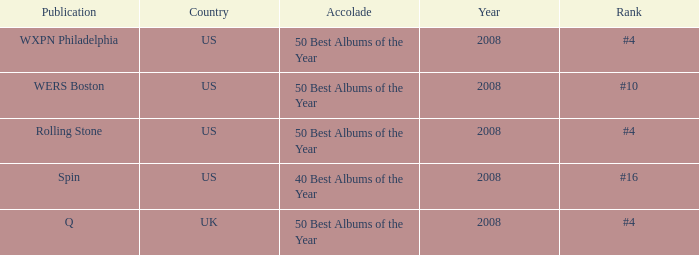In which place is the us situated when the distinction is the 40 best yearly albums? #16. 